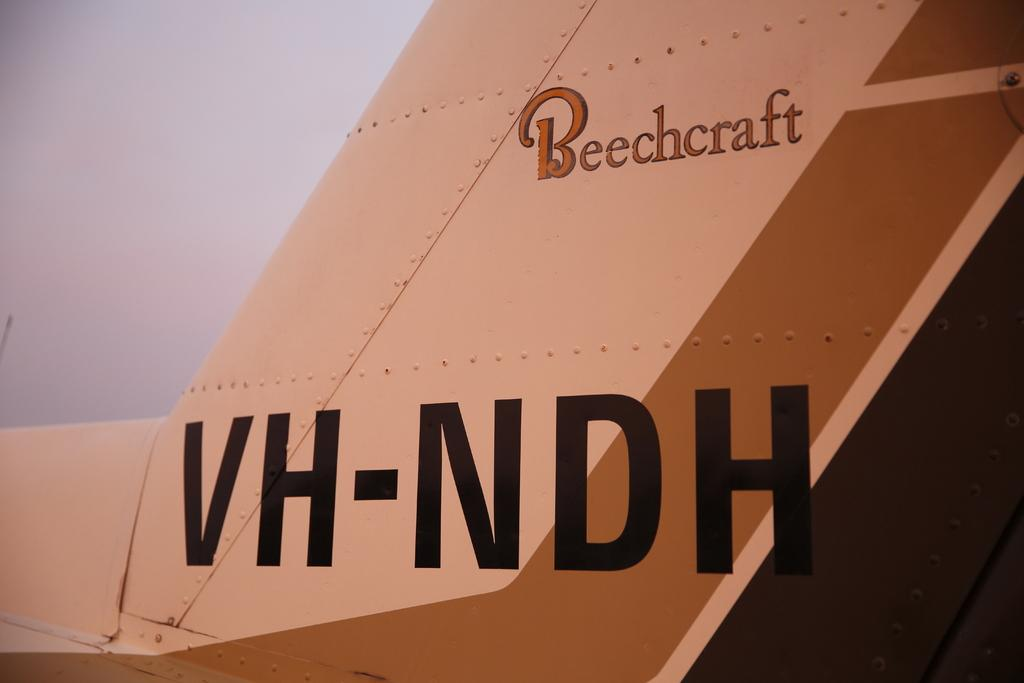What is the main subject of the image? The main subject of the image is an object that resembles an aeroplane part. Can you describe the object in more detail? Yes, the object has text on it. What type of veil is draped over the aeroplane part in the image? There is no veil present in the image; it only features an object that resembles an aeroplane part with text on it. 